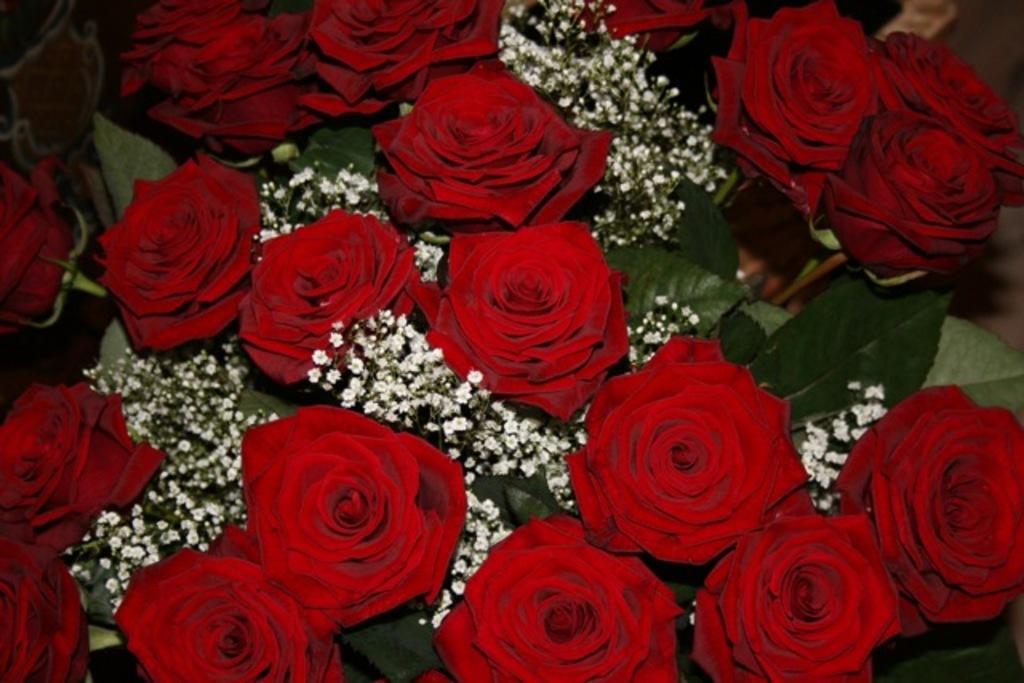How would you summarize this image in a sentence or two? In this picture we can see the red roses, green leaves and some other items. 